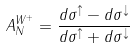Convert formula to latex. <formula><loc_0><loc_0><loc_500><loc_500>A _ { N } ^ { W ^ { + } } = \frac { d \sigma ^ { \uparrow } - d \sigma ^ { \downarrow } } { d \sigma ^ { \uparrow } + d \sigma ^ { \downarrow } }</formula> 